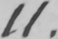Transcribe the text shown in this historical manuscript line. 11 . 